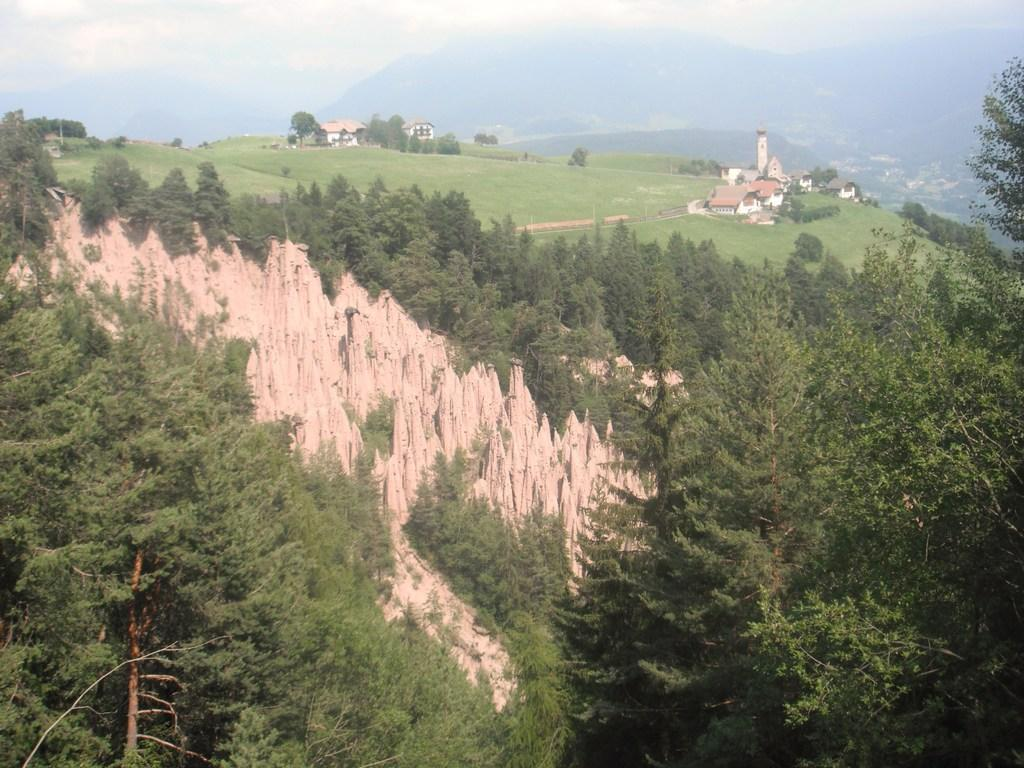What type of vegetation is present in the image? There are trees and grass in the image. What type of structures can be seen in the image? There are houses in the image. What kind of terrain is visible in the image? There are hills in the image. What is the condition of the sky in the image? The sky is cloudy in the image. How many sisters are sitting on the grass in the image? There are no sisters present in the image; it features trees, grass, houses, hills, and a cloudy sky. What type of pies can be seen on the hills in the image? There are no pies present in the image; it features trees, grass, houses, hills, and a cloudy sky. 